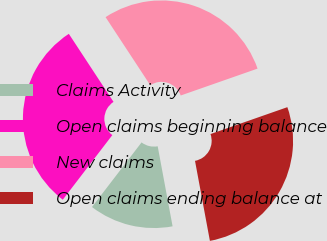<chart> <loc_0><loc_0><loc_500><loc_500><pie_chart><fcel>Claims Activity<fcel>Open claims beginning balance<fcel>New claims<fcel>Open claims ending balance at<nl><fcel>13.34%<fcel>30.34%<fcel>28.89%<fcel>27.43%<nl></chart> 